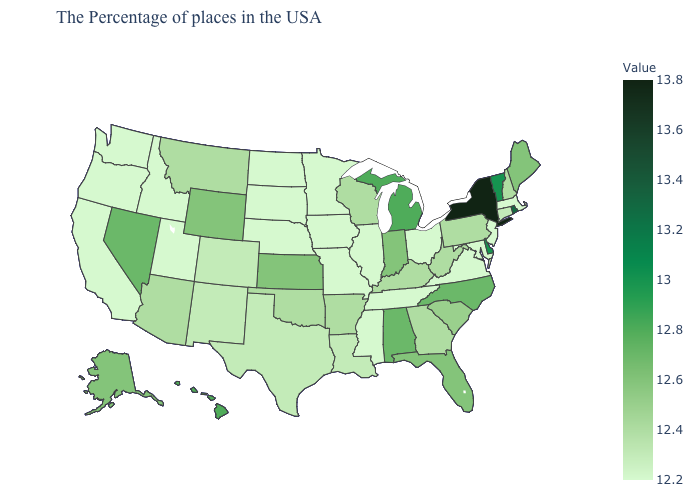Among the states that border Wyoming , which have the lowest value?
Short answer required. Nebraska, South Dakota, Utah, Idaho. Does New Jersey have a higher value than West Virginia?
Be succinct. No. Which states have the highest value in the USA?
Concise answer only. New York. Does the map have missing data?
Be succinct. No. 